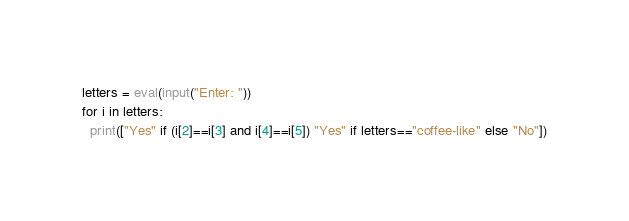Convert code to text. <code><loc_0><loc_0><loc_500><loc_500><_Python_>letters = eval(input("Enter: "))
for i in letters:
  print(["Yes" if (i[2]==i[3] and i[4]==i[5]) "Yes" if letters=="coffee-like" else "No"])</code> 